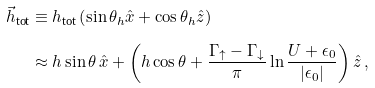Convert formula to latex. <formula><loc_0><loc_0><loc_500><loc_500>\vec { h } _ { \text {tot} } & \equiv h _ { \text {tot} } \left ( \sin \theta _ { h } \hat { x } + \cos \theta _ { h } \hat { z } \right ) \\ & \approx h \sin \theta \, \hat { x } + \left ( h \cos \theta + \frac { \Gamma _ { \uparrow } - \Gamma _ { \downarrow } } { \pi } \ln \frac { U + \epsilon _ { 0 } } { | \epsilon _ { 0 } | } \right ) \hat { z } \, ,</formula> 